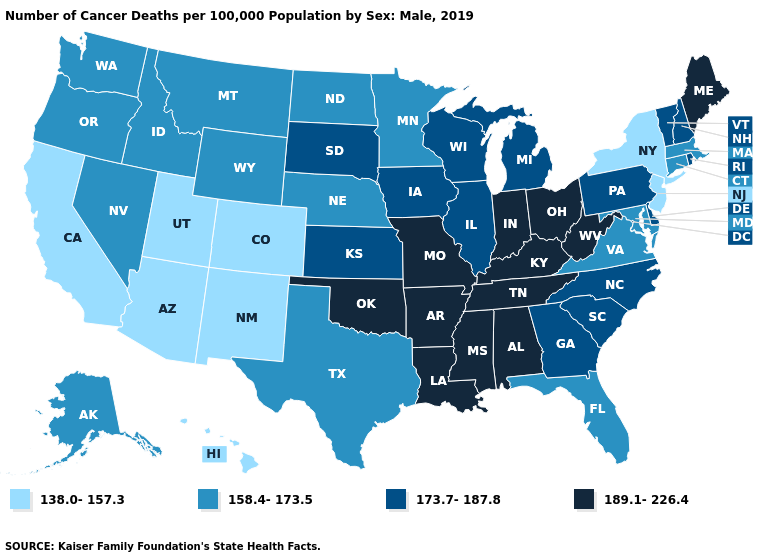What is the lowest value in the MidWest?
Concise answer only. 158.4-173.5. Does West Virginia have the highest value in the South?
Give a very brief answer. Yes. What is the highest value in states that border Florida?
Short answer required. 189.1-226.4. Does the map have missing data?
Write a very short answer. No. What is the value of Hawaii?
Concise answer only. 138.0-157.3. Does Arizona have the highest value in the West?
Write a very short answer. No. Name the states that have a value in the range 173.7-187.8?
Write a very short answer. Delaware, Georgia, Illinois, Iowa, Kansas, Michigan, New Hampshire, North Carolina, Pennsylvania, Rhode Island, South Carolina, South Dakota, Vermont, Wisconsin. What is the value of New Mexico?
Concise answer only. 138.0-157.3. Name the states that have a value in the range 138.0-157.3?
Be succinct. Arizona, California, Colorado, Hawaii, New Jersey, New Mexico, New York, Utah. Does Kansas have the lowest value in the USA?
Answer briefly. No. What is the lowest value in states that border Nebraska?
Give a very brief answer. 138.0-157.3. What is the value of Massachusetts?
Keep it brief. 158.4-173.5. Name the states that have a value in the range 173.7-187.8?
Short answer required. Delaware, Georgia, Illinois, Iowa, Kansas, Michigan, New Hampshire, North Carolina, Pennsylvania, Rhode Island, South Carolina, South Dakota, Vermont, Wisconsin. Name the states that have a value in the range 173.7-187.8?
Give a very brief answer. Delaware, Georgia, Illinois, Iowa, Kansas, Michigan, New Hampshire, North Carolina, Pennsylvania, Rhode Island, South Carolina, South Dakota, Vermont, Wisconsin. Name the states that have a value in the range 158.4-173.5?
Write a very short answer. Alaska, Connecticut, Florida, Idaho, Maryland, Massachusetts, Minnesota, Montana, Nebraska, Nevada, North Dakota, Oregon, Texas, Virginia, Washington, Wyoming. 